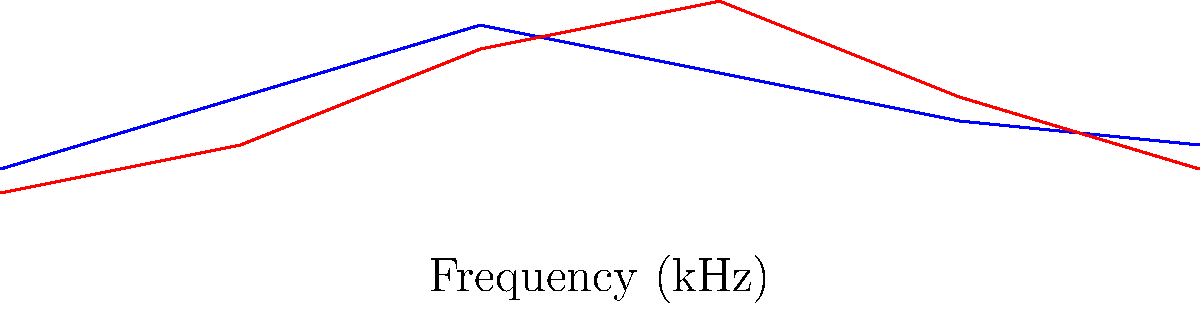Analyze the spectrogram comparison of the Russian and Bulgarian phoneme /ʃ/ (sh). What is the primary phonetic difference between these two consonants, and how does this relate to their articulation? To answer this question, we need to analyze the spectrogram and consider the articulatory features of the /ʃ/ sound in both Russian and Bulgarian:

1. Observe the spectrograms:
   - The Russian /ʃ/ (blue line) shows a lower overall frequency distribution.
   - The Bulgarian /ʃ/ (red line) displays higher frequency components, especially in the mid-range.

2. Interpret the frequency differences:
   - Lower frequencies in Russian suggest a more retracted articulation.
   - Higher frequencies in Bulgarian indicate a more forward place of articulation.

3. Consider the articulatory implications:
   - Russian /ʃ/ is likely produced with the tongue further back in the mouth, possibly with lip rounding.
   - Bulgarian /ʃ/ is likely produced with the tongue more forward, resulting in a smaller resonating cavity.

4. Relate to phonetic terminology:
   - Russian /ʃ/ can be described as a post-alveolar or even slightly retroflex fricative.
   - Bulgarian /ʃ/ is more of an alveolo-palatal fricative.

5. Consider the historical context:
   - This difference is consistent with the general tendency of Bulgarian to have more palatalized consonants compared to Russian.

Therefore, the primary phonetic difference is the place of articulation, with Bulgarian /ʃ/ being more forward (alveolo-palatal) compared to the more retracted Russian /ʃ/ (post-alveolar or slightly retroflex).
Answer: Place of articulation: Bulgarian /ʃ/ is more forward (alveolo-palatal) than Russian /ʃ/ (post-alveolar/slightly retroflex). 